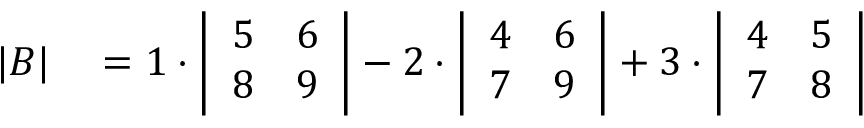<formula> <loc_0><loc_0><loc_500><loc_500>\begin{array} { r l } { | B | } & = 1 \cdot { \left | \begin{array} { l l } { 5 } & { 6 } \\ { 8 } & { 9 } \end{array} \right | } - 2 \cdot { \left | \begin{array} { l l } { 4 } & { 6 } \\ { 7 } & { 9 } \end{array} \right | } + 3 \cdot { \left | \begin{array} { l l } { 4 } & { 5 } \\ { 7 } & { 8 } \end{array} \right | } } \end{array}</formula> 